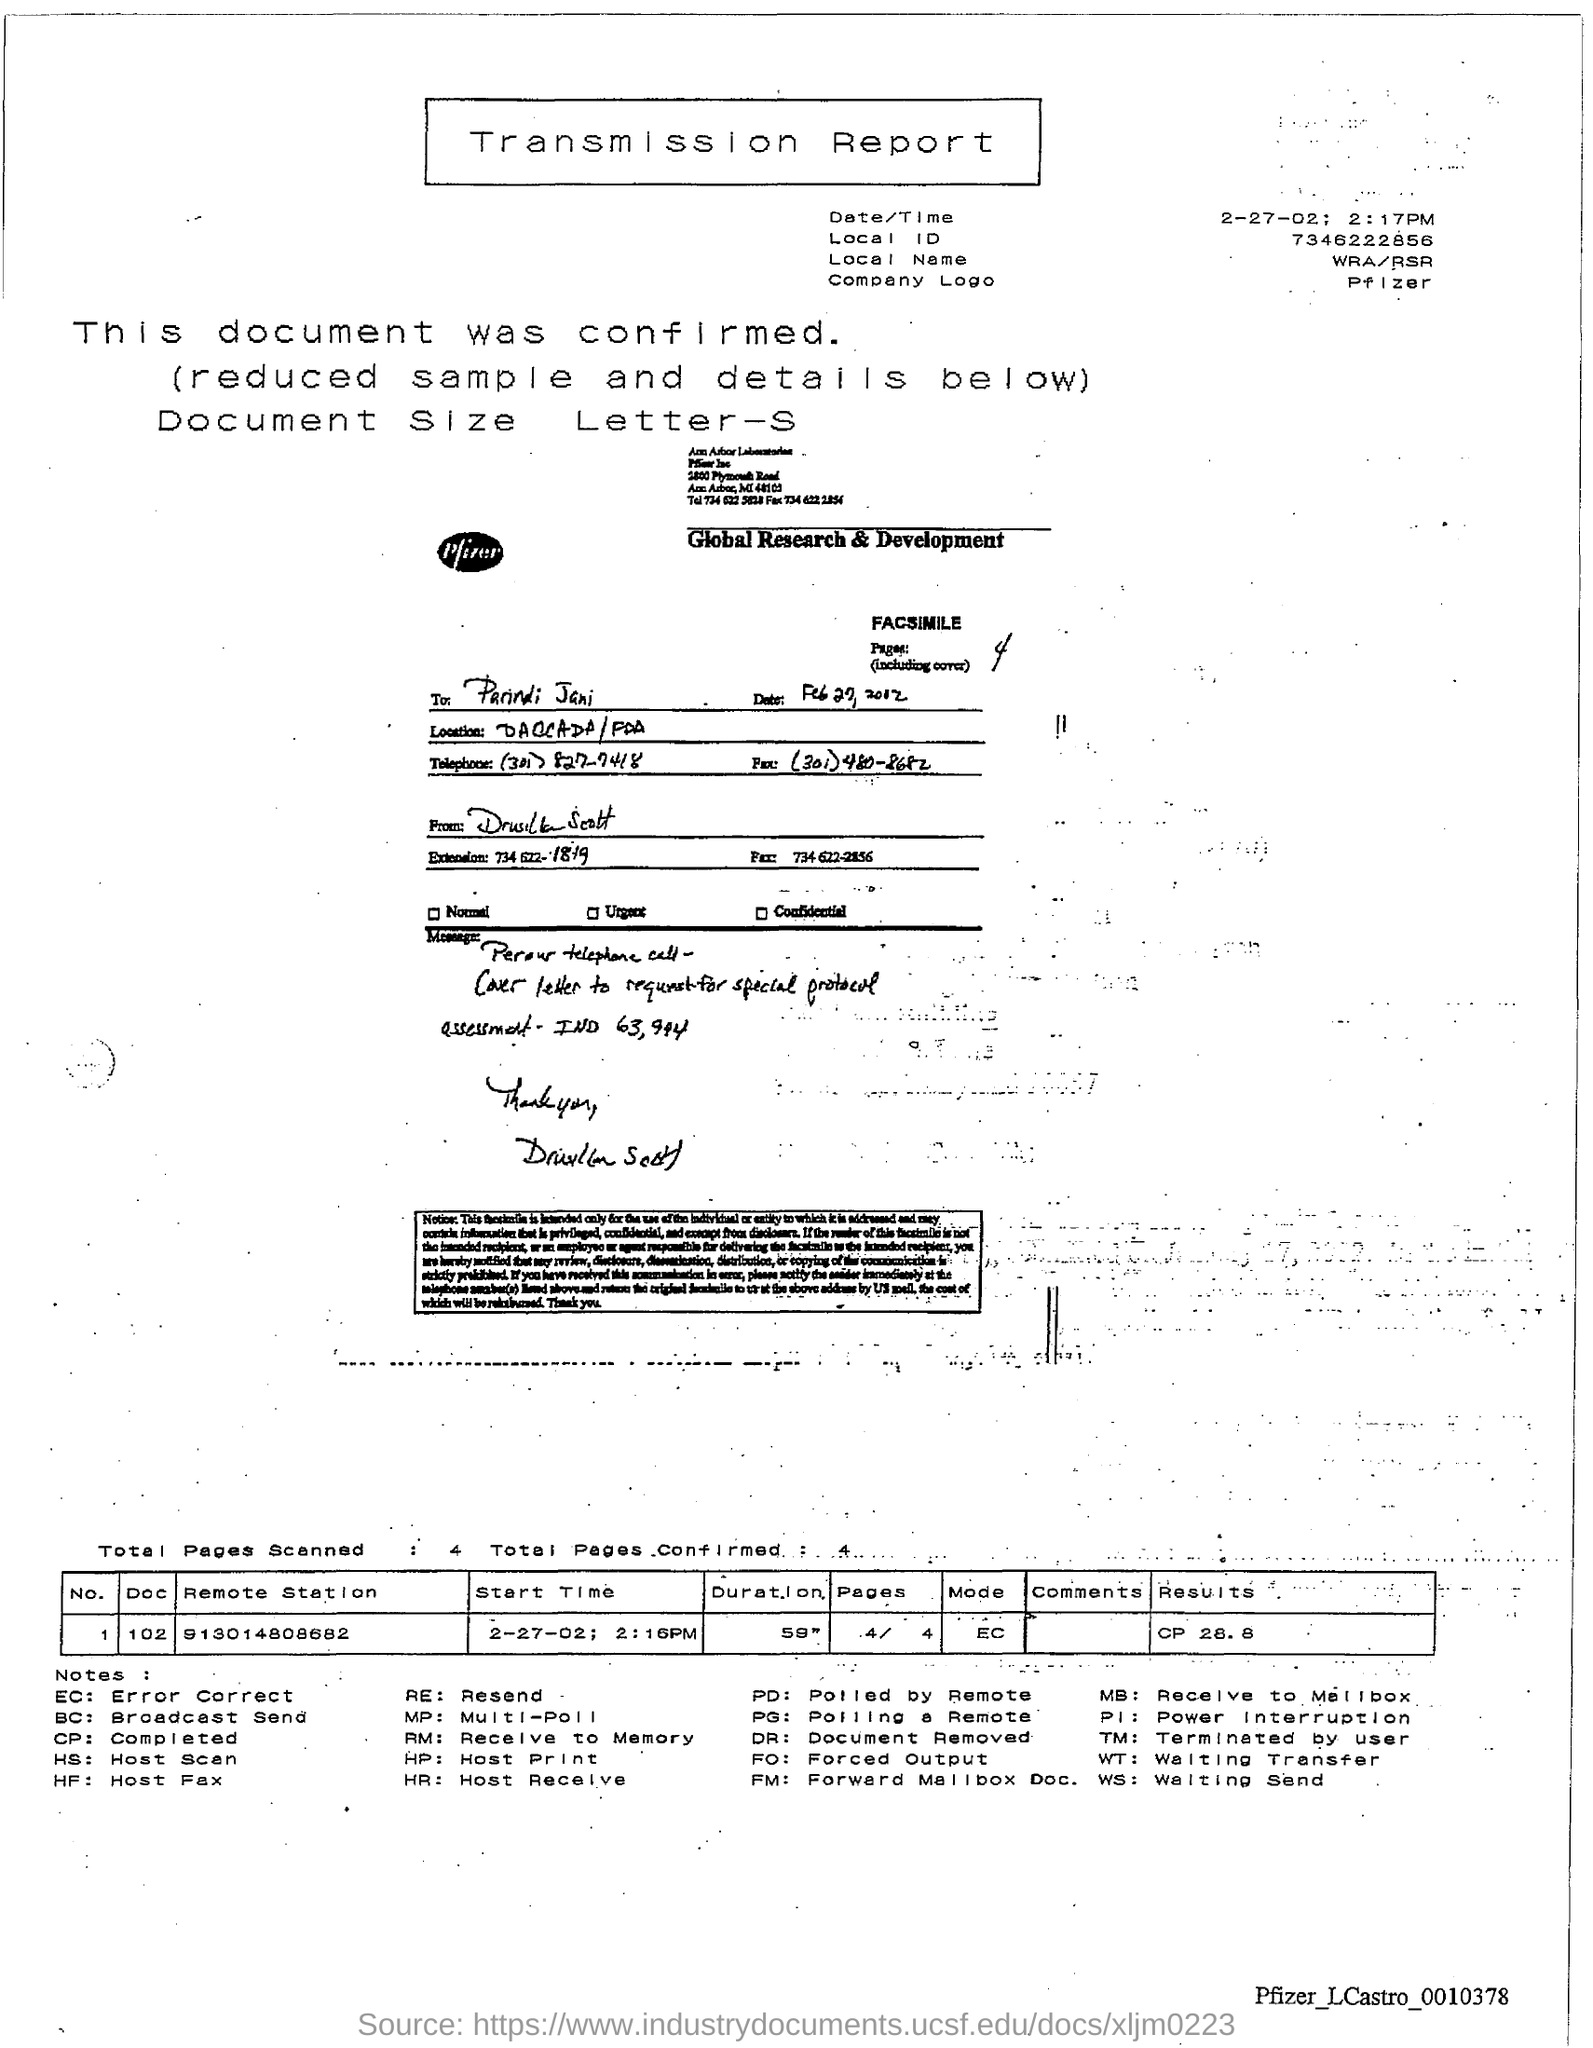What is the title of the given document?
Provide a succinct answer. TRANSMISSION REPORT. What is the local id?
Provide a succinct answer. 7346222856. What is the date/time mentioned?
Provide a short and direct response. 2-27-02; 2:17pm. What is the number mentioned in remote station?
Your answer should be very brief. 913014808682. 